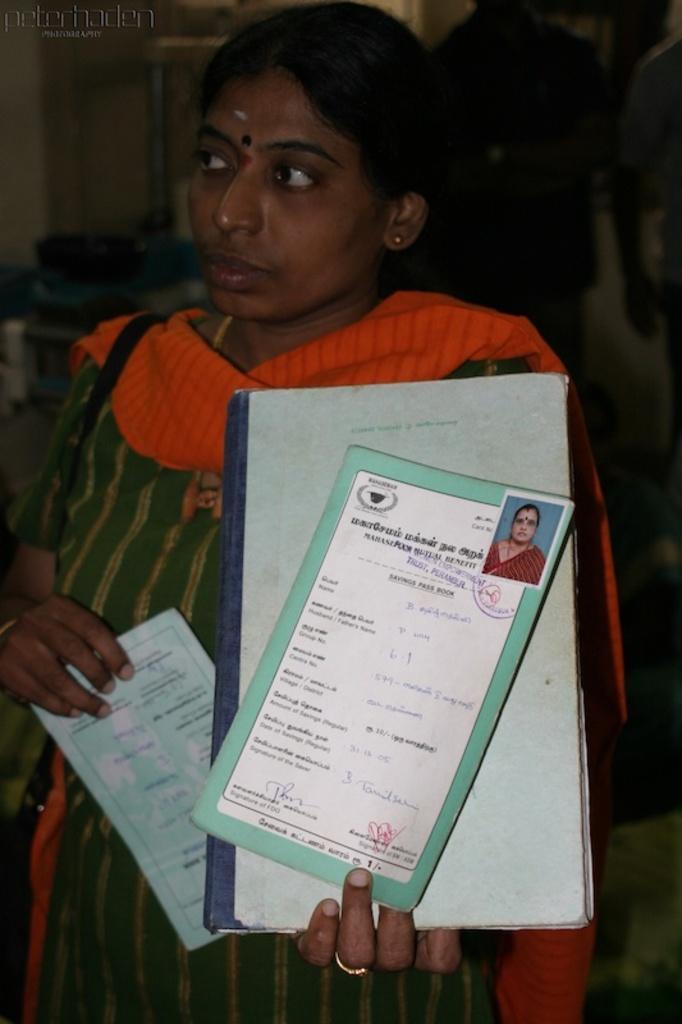In one or two sentences, can you explain what this image depicts? In the foreground of this picture we can see a woman standing, holding some objects and we can see the text and a photograph of a person attached to the paper. In the background we can see the group of persons and some other objects. In the top left corner we can see the text on the image. 